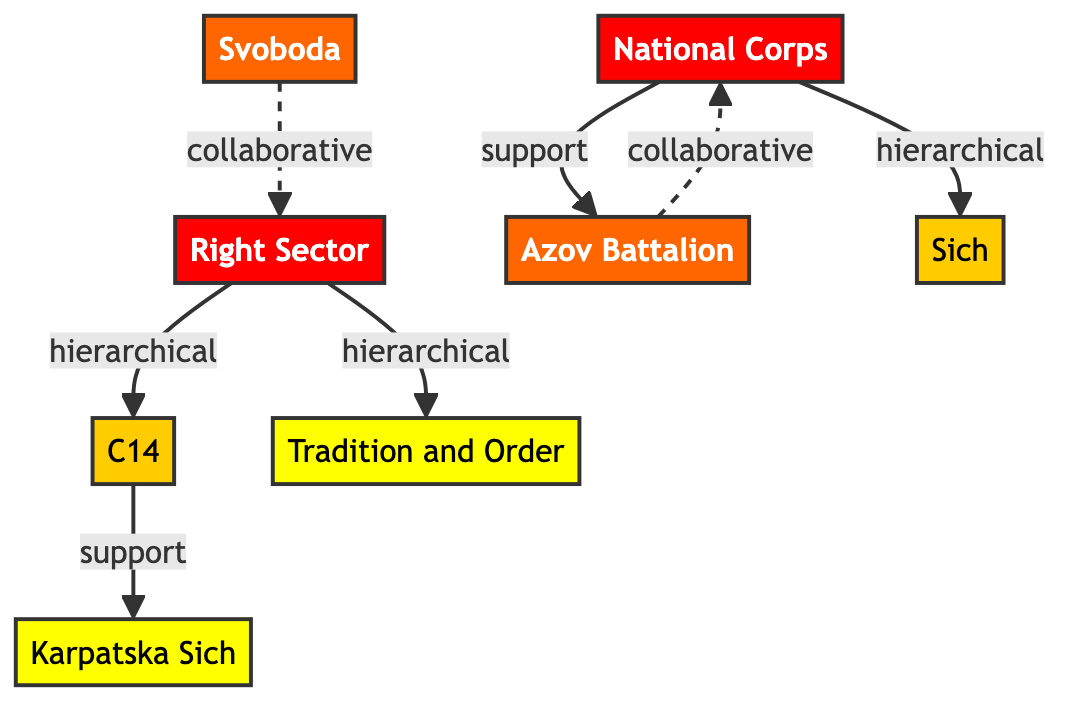What is the influence level of Right Sector? The influence level of Right Sector is provided in the diagram's node description. It indicates a numeric value of 5.
Answer: 5 How many nodes are there in the diagram? By counting each distinct entity represented in the nodes section, we find there are 8 nodes total.
Answer: 8 Which organization has a collaborative relationship with Azov Battalion? By examining the edges connected to Azov Battalion, the collaborative relationship can be traced to National Corps as indicated by the dashed line representing collaboration.
Answer: National Corps What type of relationship exists between Right Sector and C14? The directed edge from Right Sector to C14 is marked “hierarchical,” indicating a parent-child relationship in their organizational structure.
Answer: hierarchical What is the influence level of Tradition and Order? The influence level assigned to Tradition and Order is clearly listed in the node description as 2.
Answer: 2 How many support relationships are present in the diagram? When reviewing the edges, there are 2 edges specifically labeled as "support," indicating the number of such relationships.
Answer: 2 Which organization supports Karpatska Sich? The relationship between C14 and Karpatska Sich is defined as “support,” establishing C14 as the organization providing that support.
Answer: C14 What is the influence level of Svoboda compared to C14? Svoboda has an influence level of 4 while C14 has an influence level of 3, showing that Svoboda has a higher influence level than C14.
Answer: Svoboda has a higher influence level Which two organizations are indicated to have a collaborative relationship? The edges labeled as "collaborative" show the relationship between Svoboda and Right Sector, as well as Azov Battalion and National Corps.
Answer: Svoboda and Right Sector; Azov Battalion and National Corps 